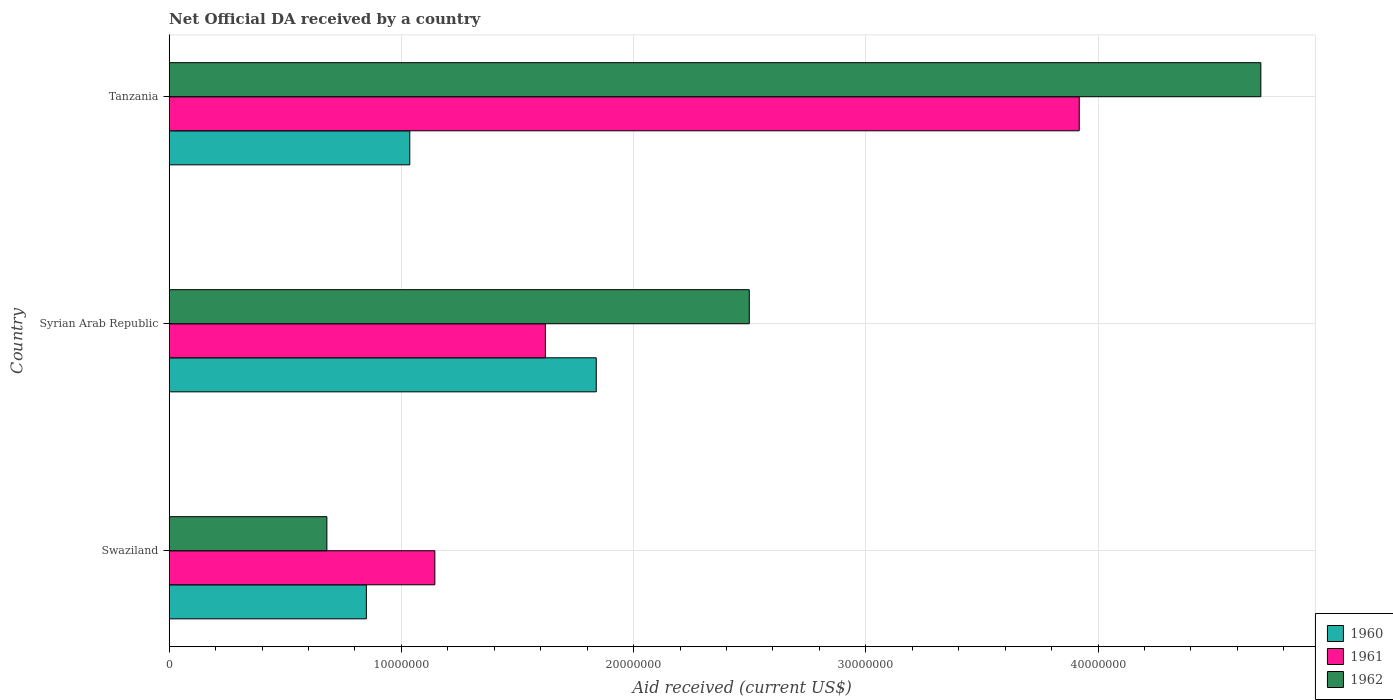How many bars are there on the 2nd tick from the top?
Keep it short and to the point. 3. What is the label of the 2nd group of bars from the top?
Offer a terse response. Syrian Arab Republic. In how many cases, is the number of bars for a given country not equal to the number of legend labels?
Your answer should be very brief. 0. What is the net official development assistance aid received in 1961 in Syrian Arab Republic?
Make the answer very short. 1.62e+07. Across all countries, what is the maximum net official development assistance aid received in 1960?
Ensure brevity in your answer.  1.84e+07. Across all countries, what is the minimum net official development assistance aid received in 1960?
Give a very brief answer. 8.49e+06. In which country was the net official development assistance aid received in 1961 maximum?
Offer a terse response. Tanzania. In which country was the net official development assistance aid received in 1960 minimum?
Your answer should be very brief. Swaziland. What is the total net official development assistance aid received in 1960 in the graph?
Your answer should be compact. 3.72e+07. What is the difference between the net official development assistance aid received in 1962 in Syrian Arab Republic and that in Tanzania?
Provide a short and direct response. -2.20e+07. What is the difference between the net official development assistance aid received in 1960 in Syrian Arab Republic and the net official development assistance aid received in 1962 in Tanzania?
Your response must be concise. -2.86e+07. What is the average net official development assistance aid received in 1962 per country?
Provide a succinct answer. 2.63e+07. What is the difference between the net official development assistance aid received in 1962 and net official development assistance aid received in 1961 in Syrian Arab Republic?
Make the answer very short. 8.78e+06. In how many countries, is the net official development assistance aid received in 1960 greater than 18000000 US$?
Your response must be concise. 1. What is the ratio of the net official development assistance aid received in 1961 in Swaziland to that in Tanzania?
Provide a short and direct response. 0.29. Is the net official development assistance aid received in 1962 in Swaziland less than that in Syrian Arab Republic?
Offer a terse response. Yes. Is the difference between the net official development assistance aid received in 1962 in Swaziland and Tanzania greater than the difference between the net official development assistance aid received in 1961 in Swaziland and Tanzania?
Ensure brevity in your answer.  No. What is the difference between the highest and the second highest net official development assistance aid received in 1960?
Give a very brief answer. 8.03e+06. What is the difference between the highest and the lowest net official development assistance aid received in 1960?
Give a very brief answer. 9.90e+06. In how many countries, is the net official development assistance aid received in 1962 greater than the average net official development assistance aid received in 1962 taken over all countries?
Your answer should be very brief. 1. What does the 3rd bar from the bottom in Syrian Arab Republic represents?
Offer a very short reply. 1962. Is it the case that in every country, the sum of the net official development assistance aid received in 1962 and net official development assistance aid received in 1961 is greater than the net official development assistance aid received in 1960?
Provide a short and direct response. Yes. How many countries are there in the graph?
Provide a short and direct response. 3. What is the difference between two consecutive major ticks on the X-axis?
Your response must be concise. 1.00e+07. Where does the legend appear in the graph?
Provide a short and direct response. Bottom right. How many legend labels are there?
Keep it short and to the point. 3. What is the title of the graph?
Keep it short and to the point. Net Official DA received by a country. What is the label or title of the X-axis?
Give a very brief answer. Aid received (current US$). What is the Aid received (current US$) of 1960 in Swaziland?
Provide a succinct answer. 8.49e+06. What is the Aid received (current US$) in 1961 in Swaziland?
Give a very brief answer. 1.14e+07. What is the Aid received (current US$) in 1962 in Swaziland?
Ensure brevity in your answer.  6.79e+06. What is the Aid received (current US$) in 1960 in Syrian Arab Republic?
Keep it short and to the point. 1.84e+07. What is the Aid received (current US$) of 1961 in Syrian Arab Republic?
Make the answer very short. 1.62e+07. What is the Aid received (current US$) of 1962 in Syrian Arab Republic?
Your answer should be very brief. 2.50e+07. What is the Aid received (current US$) in 1960 in Tanzania?
Your answer should be very brief. 1.04e+07. What is the Aid received (current US$) in 1961 in Tanzania?
Give a very brief answer. 3.92e+07. What is the Aid received (current US$) in 1962 in Tanzania?
Ensure brevity in your answer.  4.70e+07. Across all countries, what is the maximum Aid received (current US$) of 1960?
Ensure brevity in your answer.  1.84e+07. Across all countries, what is the maximum Aid received (current US$) of 1961?
Provide a succinct answer. 3.92e+07. Across all countries, what is the maximum Aid received (current US$) in 1962?
Your answer should be compact. 4.70e+07. Across all countries, what is the minimum Aid received (current US$) in 1960?
Your response must be concise. 8.49e+06. Across all countries, what is the minimum Aid received (current US$) in 1961?
Offer a very short reply. 1.14e+07. Across all countries, what is the minimum Aid received (current US$) of 1962?
Keep it short and to the point. 6.79e+06. What is the total Aid received (current US$) of 1960 in the graph?
Provide a succinct answer. 3.72e+07. What is the total Aid received (current US$) in 1961 in the graph?
Offer a very short reply. 6.68e+07. What is the total Aid received (current US$) of 1962 in the graph?
Provide a succinct answer. 7.88e+07. What is the difference between the Aid received (current US$) of 1960 in Swaziland and that in Syrian Arab Republic?
Offer a terse response. -9.90e+06. What is the difference between the Aid received (current US$) in 1961 in Swaziland and that in Syrian Arab Republic?
Your answer should be compact. -4.76e+06. What is the difference between the Aid received (current US$) of 1962 in Swaziland and that in Syrian Arab Republic?
Your answer should be compact. -1.82e+07. What is the difference between the Aid received (current US$) of 1960 in Swaziland and that in Tanzania?
Ensure brevity in your answer.  -1.87e+06. What is the difference between the Aid received (current US$) in 1961 in Swaziland and that in Tanzania?
Your response must be concise. -2.78e+07. What is the difference between the Aid received (current US$) of 1962 in Swaziland and that in Tanzania?
Give a very brief answer. -4.02e+07. What is the difference between the Aid received (current US$) of 1960 in Syrian Arab Republic and that in Tanzania?
Offer a terse response. 8.03e+06. What is the difference between the Aid received (current US$) in 1961 in Syrian Arab Republic and that in Tanzania?
Your response must be concise. -2.30e+07. What is the difference between the Aid received (current US$) of 1962 in Syrian Arab Republic and that in Tanzania?
Keep it short and to the point. -2.20e+07. What is the difference between the Aid received (current US$) of 1960 in Swaziland and the Aid received (current US$) of 1961 in Syrian Arab Republic?
Give a very brief answer. -7.71e+06. What is the difference between the Aid received (current US$) in 1960 in Swaziland and the Aid received (current US$) in 1962 in Syrian Arab Republic?
Ensure brevity in your answer.  -1.65e+07. What is the difference between the Aid received (current US$) of 1961 in Swaziland and the Aid received (current US$) of 1962 in Syrian Arab Republic?
Make the answer very short. -1.35e+07. What is the difference between the Aid received (current US$) in 1960 in Swaziland and the Aid received (current US$) in 1961 in Tanzania?
Keep it short and to the point. -3.07e+07. What is the difference between the Aid received (current US$) in 1960 in Swaziland and the Aid received (current US$) in 1962 in Tanzania?
Offer a terse response. -3.85e+07. What is the difference between the Aid received (current US$) in 1961 in Swaziland and the Aid received (current US$) in 1962 in Tanzania?
Offer a terse response. -3.56e+07. What is the difference between the Aid received (current US$) in 1960 in Syrian Arab Republic and the Aid received (current US$) in 1961 in Tanzania?
Provide a succinct answer. -2.08e+07. What is the difference between the Aid received (current US$) in 1960 in Syrian Arab Republic and the Aid received (current US$) in 1962 in Tanzania?
Offer a very short reply. -2.86e+07. What is the difference between the Aid received (current US$) in 1961 in Syrian Arab Republic and the Aid received (current US$) in 1962 in Tanzania?
Provide a succinct answer. -3.08e+07. What is the average Aid received (current US$) of 1960 per country?
Offer a very short reply. 1.24e+07. What is the average Aid received (current US$) of 1961 per country?
Offer a very short reply. 2.23e+07. What is the average Aid received (current US$) in 1962 per country?
Your response must be concise. 2.63e+07. What is the difference between the Aid received (current US$) of 1960 and Aid received (current US$) of 1961 in Swaziland?
Provide a succinct answer. -2.95e+06. What is the difference between the Aid received (current US$) of 1960 and Aid received (current US$) of 1962 in Swaziland?
Give a very brief answer. 1.70e+06. What is the difference between the Aid received (current US$) of 1961 and Aid received (current US$) of 1962 in Swaziland?
Give a very brief answer. 4.65e+06. What is the difference between the Aid received (current US$) of 1960 and Aid received (current US$) of 1961 in Syrian Arab Republic?
Give a very brief answer. 2.19e+06. What is the difference between the Aid received (current US$) in 1960 and Aid received (current US$) in 1962 in Syrian Arab Republic?
Your answer should be compact. -6.59e+06. What is the difference between the Aid received (current US$) in 1961 and Aid received (current US$) in 1962 in Syrian Arab Republic?
Your answer should be compact. -8.78e+06. What is the difference between the Aid received (current US$) of 1960 and Aid received (current US$) of 1961 in Tanzania?
Your answer should be compact. -2.88e+07. What is the difference between the Aid received (current US$) of 1960 and Aid received (current US$) of 1962 in Tanzania?
Provide a succinct answer. -3.66e+07. What is the difference between the Aid received (current US$) of 1961 and Aid received (current US$) of 1962 in Tanzania?
Provide a short and direct response. -7.82e+06. What is the ratio of the Aid received (current US$) of 1960 in Swaziland to that in Syrian Arab Republic?
Offer a very short reply. 0.46. What is the ratio of the Aid received (current US$) of 1961 in Swaziland to that in Syrian Arab Republic?
Offer a very short reply. 0.71. What is the ratio of the Aid received (current US$) in 1962 in Swaziland to that in Syrian Arab Republic?
Your answer should be compact. 0.27. What is the ratio of the Aid received (current US$) of 1960 in Swaziland to that in Tanzania?
Your answer should be very brief. 0.82. What is the ratio of the Aid received (current US$) in 1961 in Swaziland to that in Tanzania?
Offer a terse response. 0.29. What is the ratio of the Aid received (current US$) in 1962 in Swaziland to that in Tanzania?
Provide a succinct answer. 0.14. What is the ratio of the Aid received (current US$) of 1960 in Syrian Arab Republic to that in Tanzania?
Your answer should be compact. 1.78. What is the ratio of the Aid received (current US$) of 1961 in Syrian Arab Republic to that in Tanzania?
Give a very brief answer. 0.41. What is the ratio of the Aid received (current US$) of 1962 in Syrian Arab Republic to that in Tanzania?
Keep it short and to the point. 0.53. What is the difference between the highest and the second highest Aid received (current US$) of 1960?
Make the answer very short. 8.03e+06. What is the difference between the highest and the second highest Aid received (current US$) of 1961?
Your answer should be very brief. 2.30e+07. What is the difference between the highest and the second highest Aid received (current US$) of 1962?
Give a very brief answer. 2.20e+07. What is the difference between the highest and the lowest Aid received (current US$) of 1960?
Offer a terse response. 9.90e+06. What is the difference between the highest and the lowest Aid received (current US$) in 1961?
Your answer should be compact. 2.78e+07. What is the difference between the highest and the lowest Aid received (current US$) in 1962?
Provide a succinct answer. 4.02e+07. 